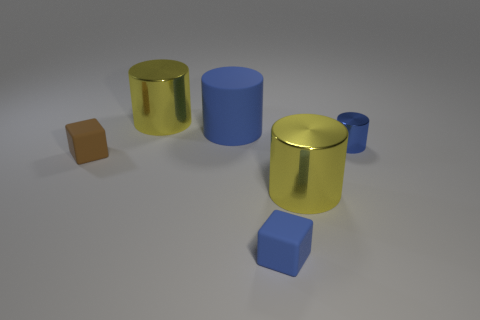Subtract all yellow cylinders. How many were subtracted if there are1yellow cylinders left? 1 Subtract all small blue cylinders. How many cylinders are left? 3 Subtract 0 cyan balls. How many objects are left? 6 Subtract all cylinders. How many objects are left? 2 Subtract 2 cubes. How many cubes are left? 0 Subtract all brown cylinders. Subtract all cyan balls. How many cylinders are left? 4 Subtract all green spheres. How many blue blocks are left? 1 Subtract all large blue things. Subtract all yellow rubber spheres. How many objects are left? 5 Add 2 tiny cubes. How many tiny cubes are left? 4 Add 4 big purple cylinders. How many big purple cylinders exist? 4 